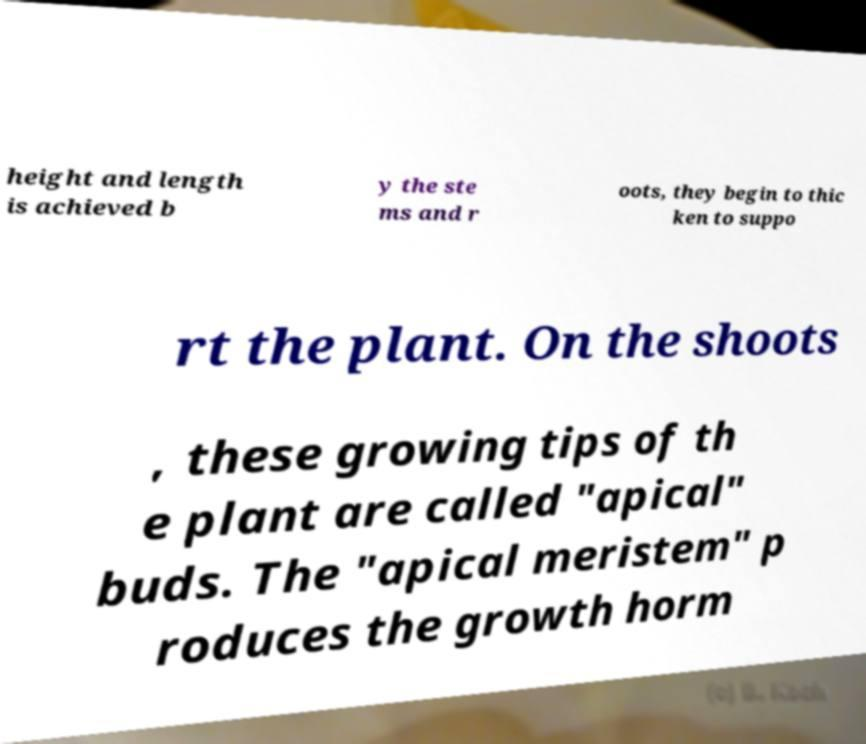Can you read and provide the text displayed in the image?This photo seems to have some interesting text. Can you extract and type it out for me? height and length is achieved b y the ste ms and r oots, they begin to thic ken to suppo rt the plant. On the shoots , these growing tips of th e plant are called "apical" buds. The "apical meristem" p roduces the growth horm 